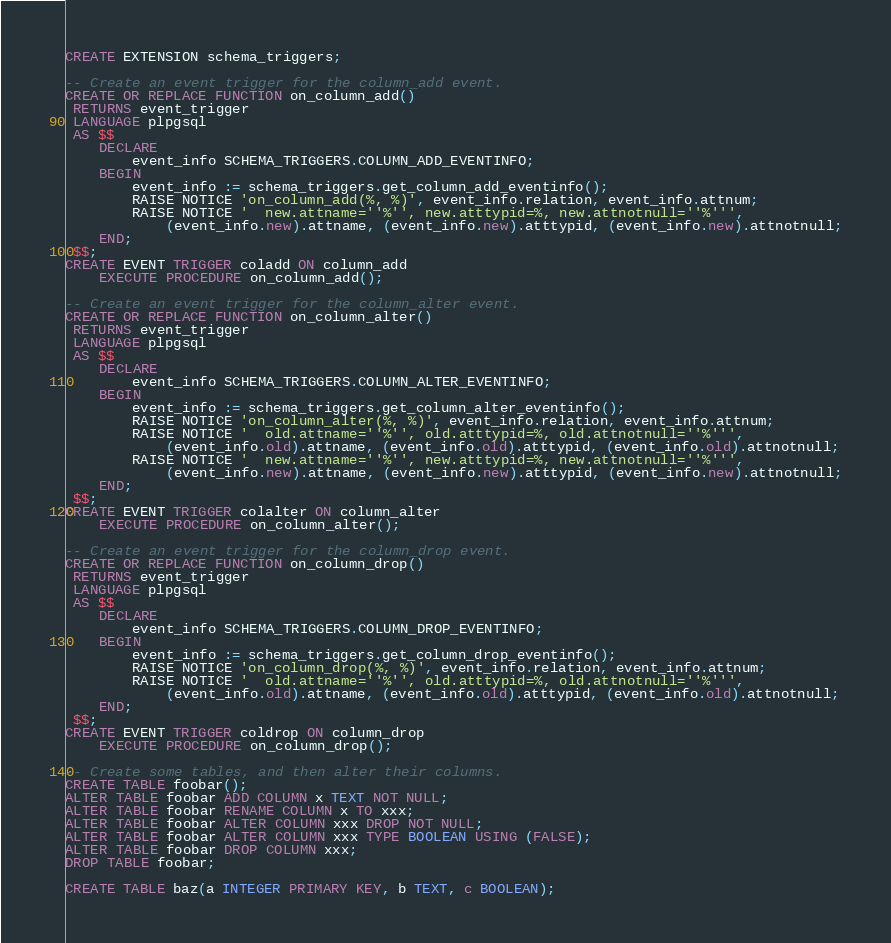Convert code to text. <code><loc_0><loc_0><loc_500><loc_500><_SQL_>CREATE EXTENSION schema_triggers;

-- Create an event trigger for the column_add event.
CREATE OR REPLACE FUNCTION on_column_add()
 RETURNS event_trigger
 LANGUAGE plpgsql
 AS $$
	DECLARE
		event_info SCHEMA_TRIGGERS.COLUMN_ADD_EVENTINFO;
	BEGIN
		event_info := schema_triggers.get_column_add_eventinfo();
		RAISE NOTICE 'on_column_add(%, %)', event_info.relation, event_info.attnum;
		RAISE NOTICE '  new.attname=''%'', new.atttypid=%, new.attnotnull=''%''',
	 		(event_info.new).attname, (event_info.new).atttypid, (event_info.new).attnotnull;
	END;
 $$;
CREATE EVENT TRIGGER coladd ON column_add
	EXECUTE PROCEDURE on_column_add();

-- Create an event trigger for the column_alter event.
CREATE OR REPLACE FUNCTION on_column_alter()
 RETURNS event_trigger
 LANGUAGE plpgsql
 AS $$
	DECLARE
		event_info SCHEMA_TRIGGERS.COLUMN_ALTER_EVENTINFO;
	BEGIN
		event_info := schema_triggers.get_column_alter_eventinfo();
		RAISE NOTICE 'on_column_alter(%, %)', event_info.relation, event_info.attnum;
		RAISE NOTICE '  old.attname=''%'', old.atttypid=%, old.attnotnull=''%''',
	 		(event_info.old).attname, (event_info.old).atttypid, (event_info.old).attnotnull;
		RAISE NOTICE '  new.attname=''%'', new.atttypid=%, new.attnotnull=''%''',
	 		(event_info.new).attname, (event_info.new).atttypid, (event_info.new).attnotnull;
	END;
 $$;
CREATE EVENT TRIGGER colalter ON column_alter
	EXECUTE PROCEDURE on_column_alter();

-- Create an event trigger for the column_drop event.
CREATE OR REPLACE FUNCTION on_column_drop()
 RETURNS event_trigger
 LANGUAGE plpgsql
 AS $$
	DECLARE
		event_info SCHEMA_TRIGGERS.COLUMN_DROP_EVENTINFO;
	BEGIN
		event_info := schema_triggers.get_column_drop_eventinfo();
		RAISE NOTICE 'on_column_drop(%, %)', event_info.relation, event_info.attnum;
		RAISE NOTICE '  old.attname=''%'', old.atttypid=%, old.attnotnull=''%''',
	 		(event_info.old).attname, (event_info.old).atttypid, (event_info.old).attnotnull;
	END;
 $$;
CREATE EVENT TRIGGER coldrop ON column_drop
	EXECUTE PROCEDURE on_column_drop();

-- Create some tables, and then alter their columns.
CREATE TABLE foobar();
ALTER TABLE foobar ADD COLUMN x TEXT NOT NULL;
ALTER TABLE foobar RENAME COLUMN x TO xxx;
ALTER TABLE foobar ALTER COLUMN xxx DROP NOT NULL;
ALTER TABLE foobar ALTER COLUMN xxx TYPE BOOLEAN USING (FALSE);
ALTER TABLE foobar DROP COLUMN xxx;
DROP TABLE foobar;

CREATE TABLE baz(a INTEGER PRIMARY KEY, b TEXT, c BOOLEAN);</code> 